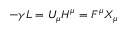<formula> <loc_0><loc_0><loc_500><loc_500>- \gamma L = U _ { \mu } H ^ { \mu } = F ^ { \mu } X _ { \mu }</formula> 